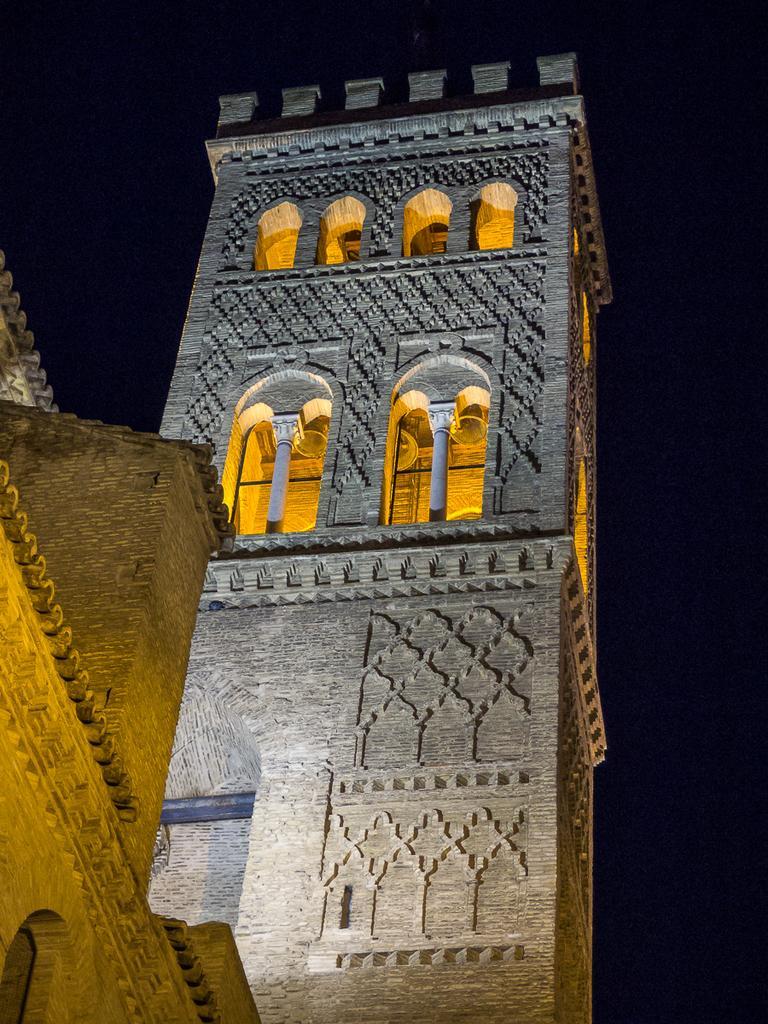Can you describe this image briefly? In the middle of this image, there is a building having windows. In this building, there is lighting arranged. Beside this building, there is another building. And the background is dark in color. 